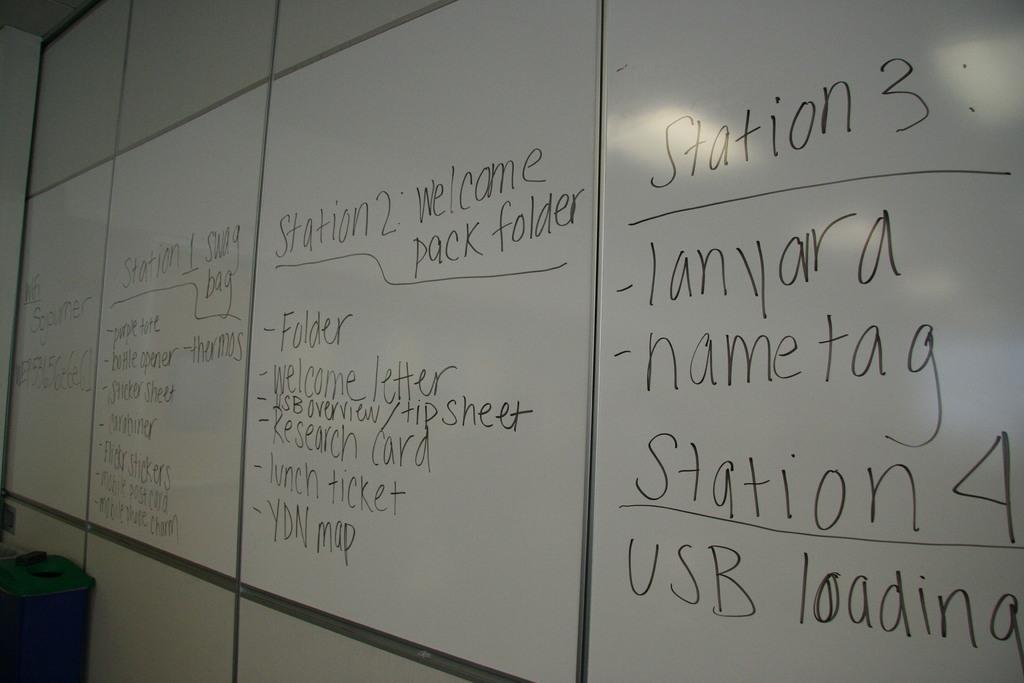<image>
Provide a brief description of the given image. A classroom white board with Station 1, 2 and 3 written in black ink along the top. 